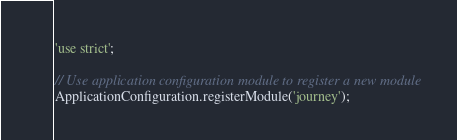Convert code to text. <code><loc_0><loc_0><loc_500><loc_500><_JavaScript_>'use strict';

// Use application configuration module to register a new module
ApplicationConfiguration.registerModule('journey');
</code> 